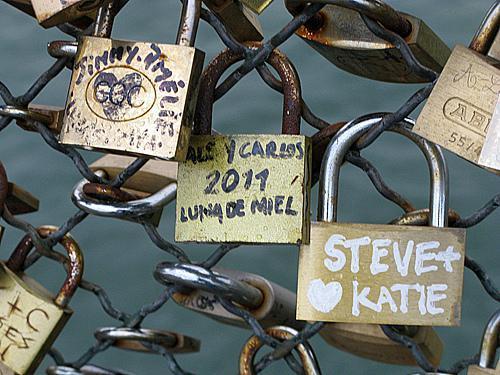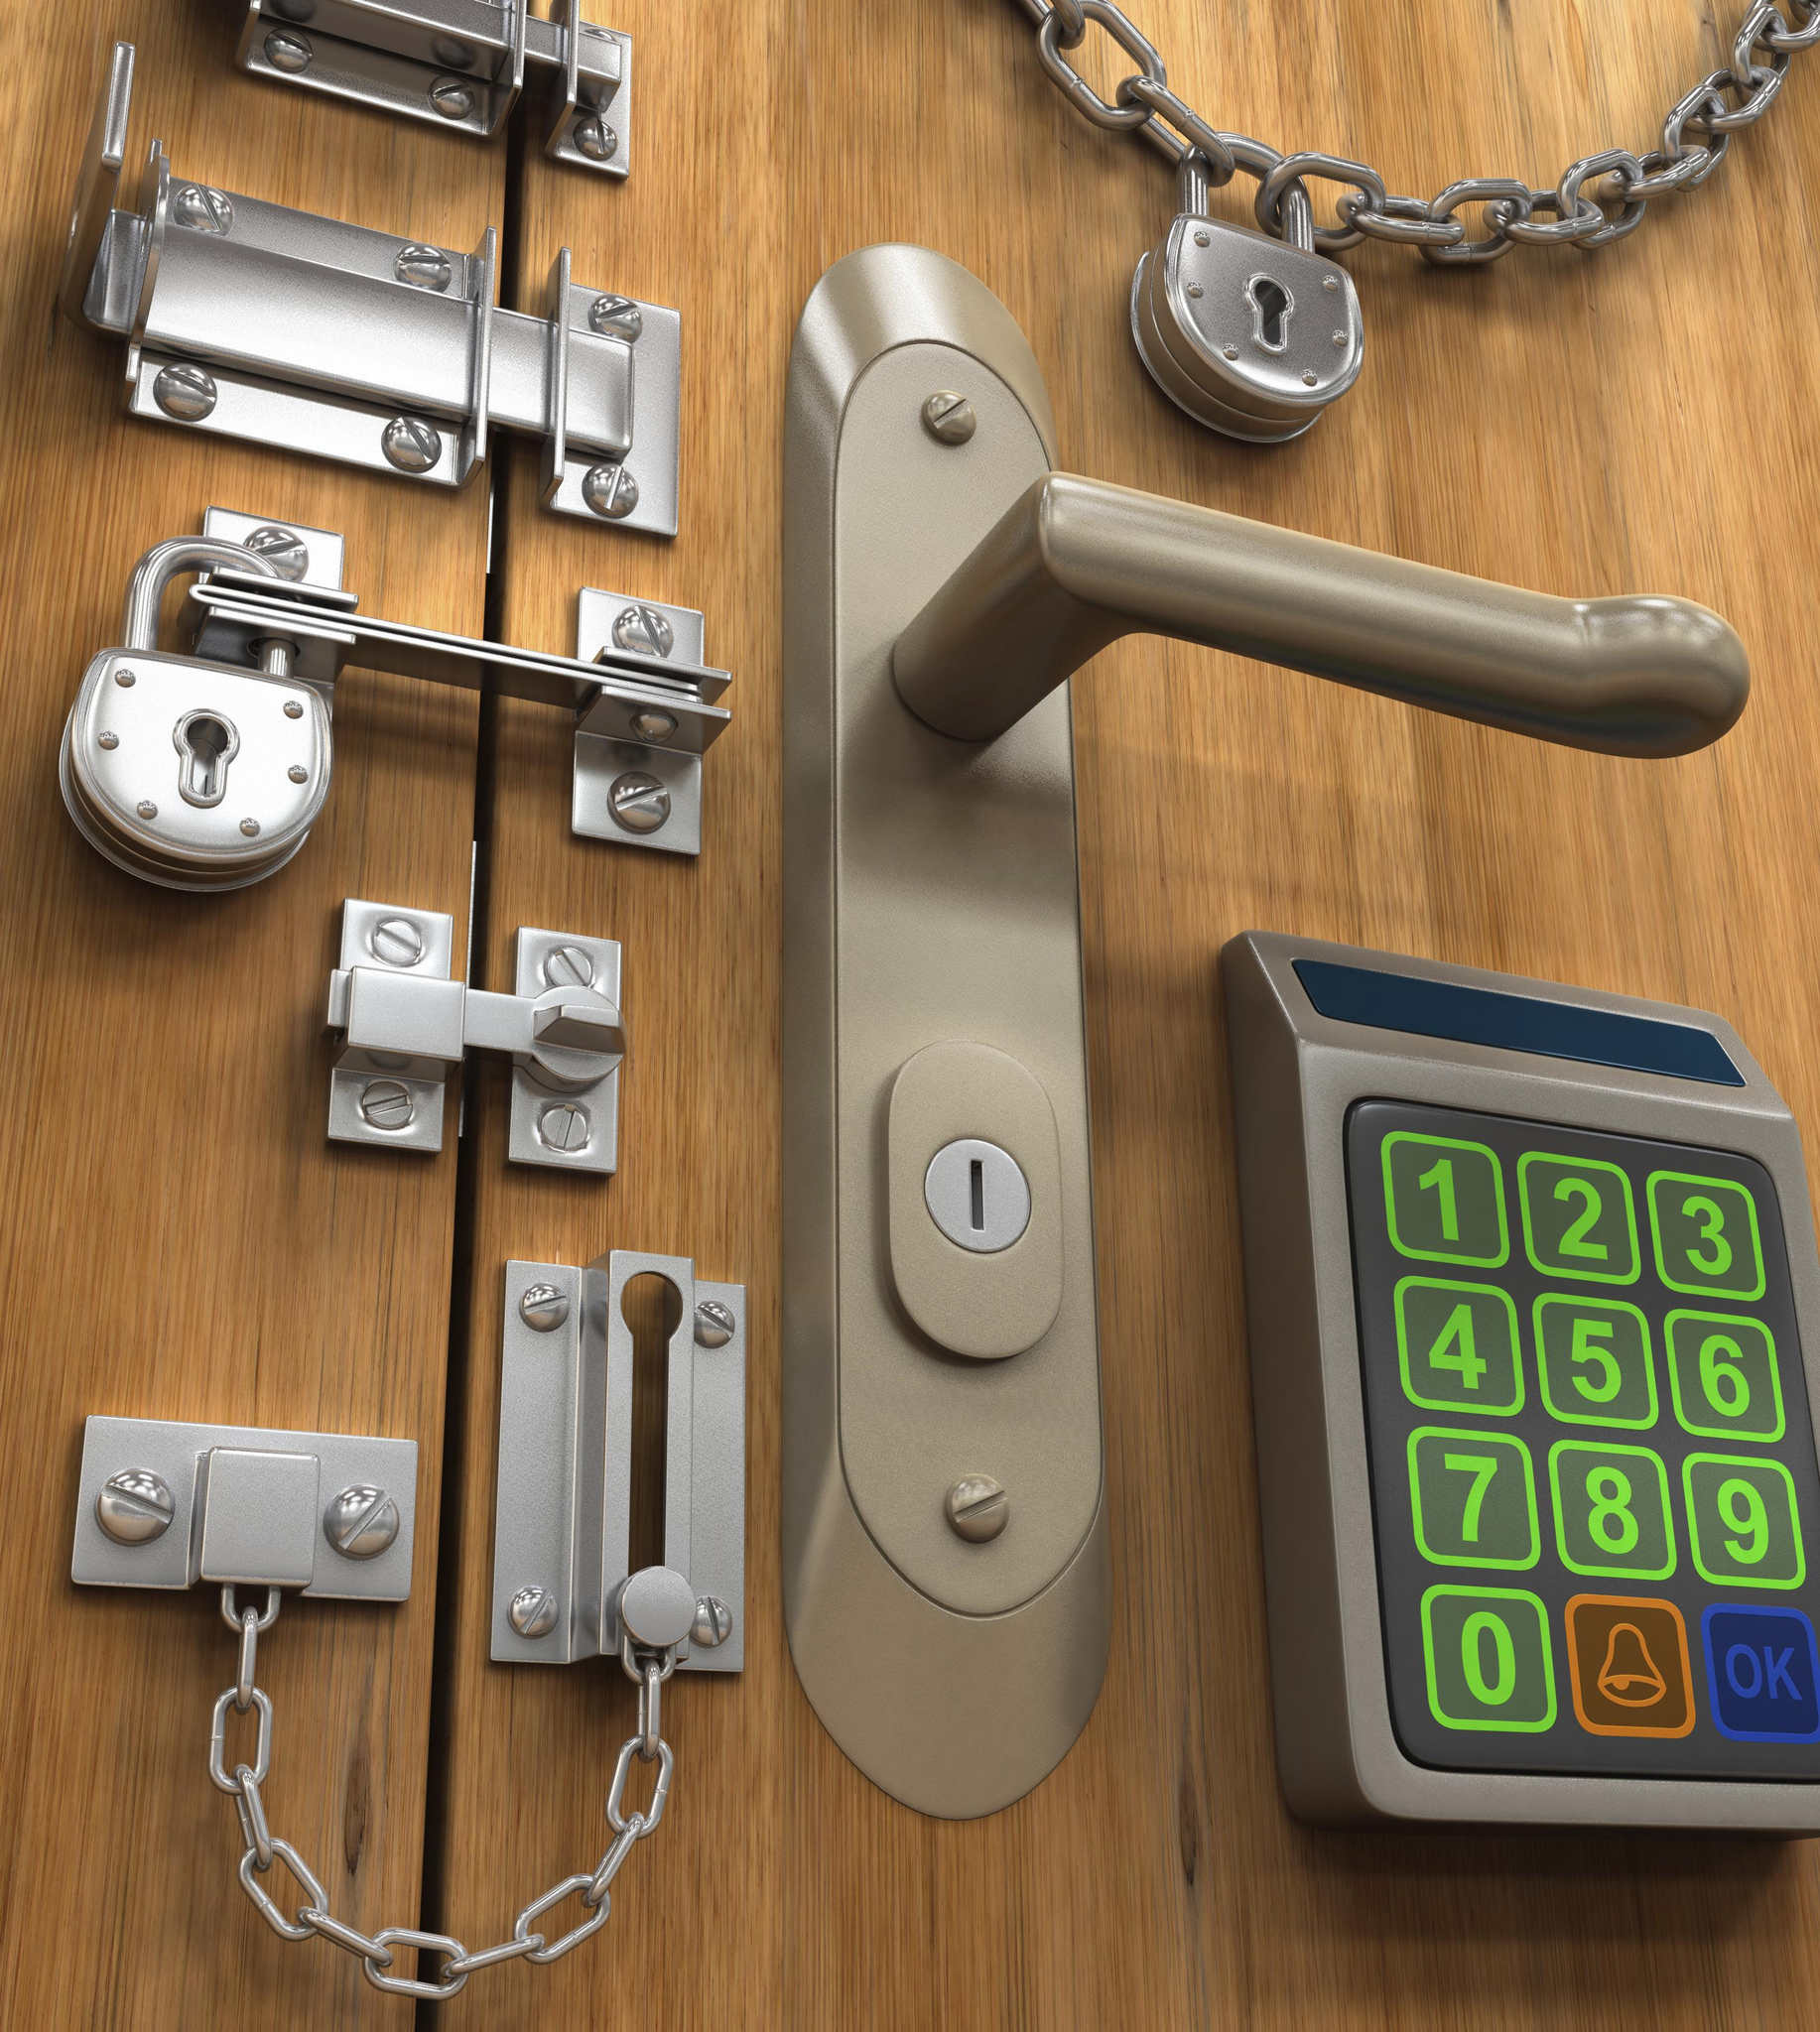The first image is the image on the left, the second image is the image on the right. Given the left and right images, does the statement "Multiple squarish padlocks are attached to openings in something made of greenish metal." hold true? Answer yes or no. No. The first image is the image on the left, the second image is the image on the right. Analyze the images presented: Is the assertion "One image contains exactly one padlock." valid? Answer yes or no. No. 